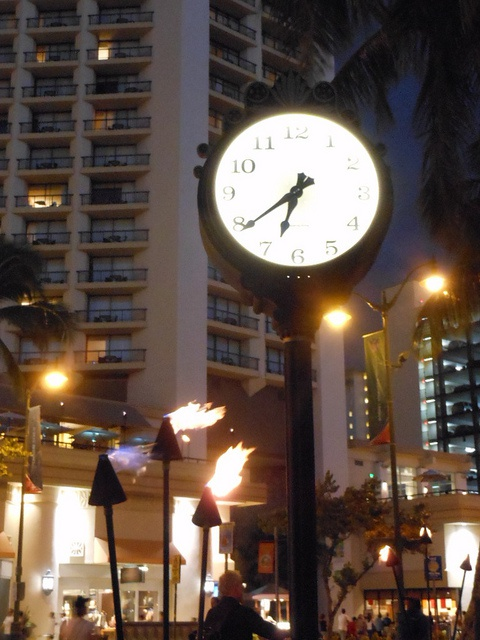Describe the objects in this image and their specific colors. I can see clock in black, white, and gray tones, people in black, maroon, and brown tones, people in black, maroon, and tan tones, people in black, brown, and maroon tones, and people in black, gray, maroon, and tan tones in this image. 